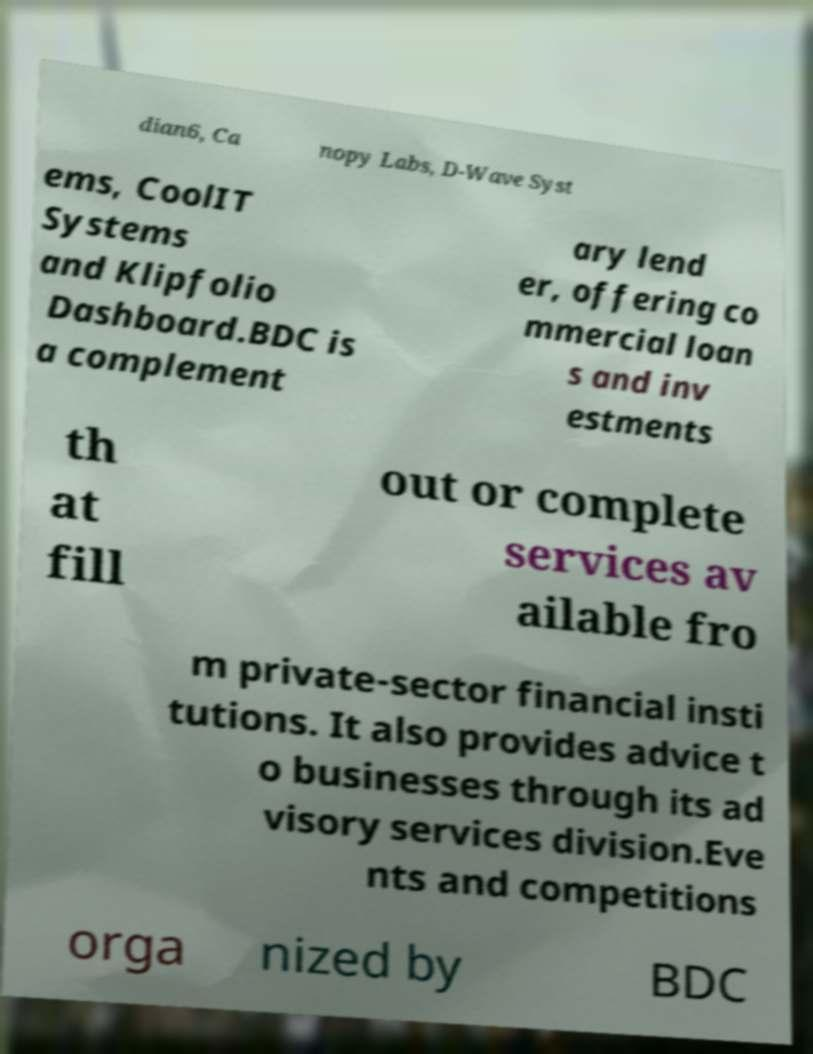I need the written content from this picture converted into text. Can you do that? dian6, Ca nopy Labs, D-Wave Syst ems, CoolIT Systems and Klipfolio Dashboard.BDC is a complement ary lend er, offering co mmercial loan s and inv estments th at fill out or complete services av ailable fro m private-sector financial insti tutions. It also provides advice t o businesses through its ad visory services division.Eve nts and competitions orga nized by BDC 